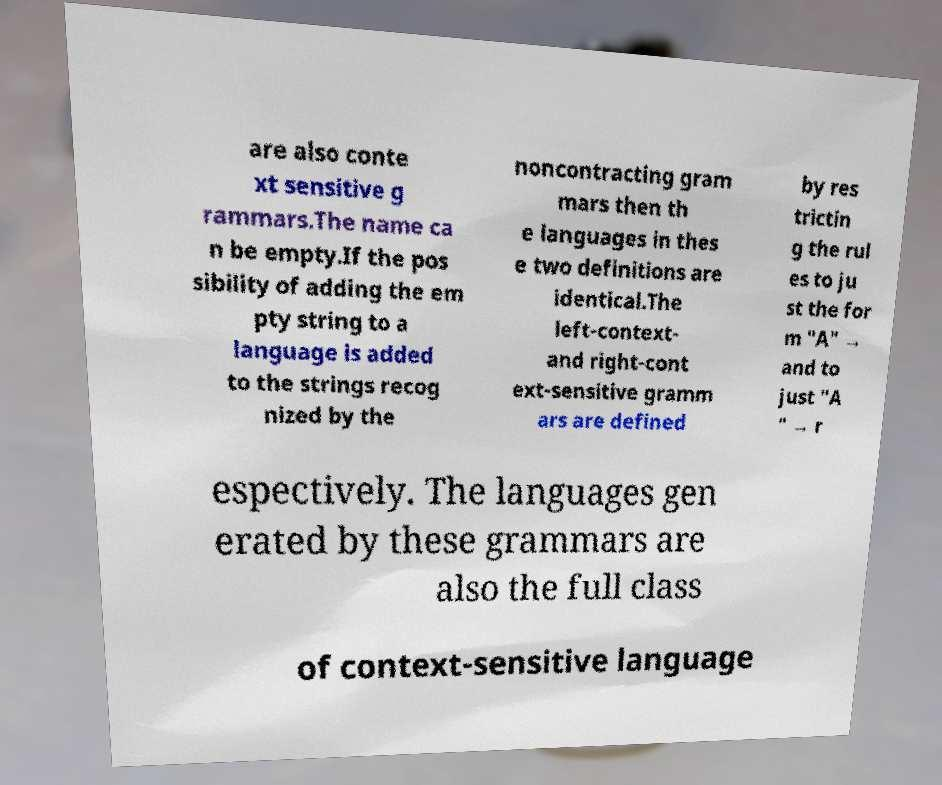Please read and relay the text visible in this image. What does it say? are also conte xt sensitive g rammars.The name ca n be empty.If the pos sibility of adding the em pty string to a language is added to the strings recog nized by the noncontracting gram mars then th e languages in thes e two definitions are identical.The left-context- and right-cont ext-sensitive gramm ars are defined by res trictin g the rul es to ju st the for m "A" → and to just "A " → r espectively. The languages gen erated by these grammars are also the full class of context-sensitive language 